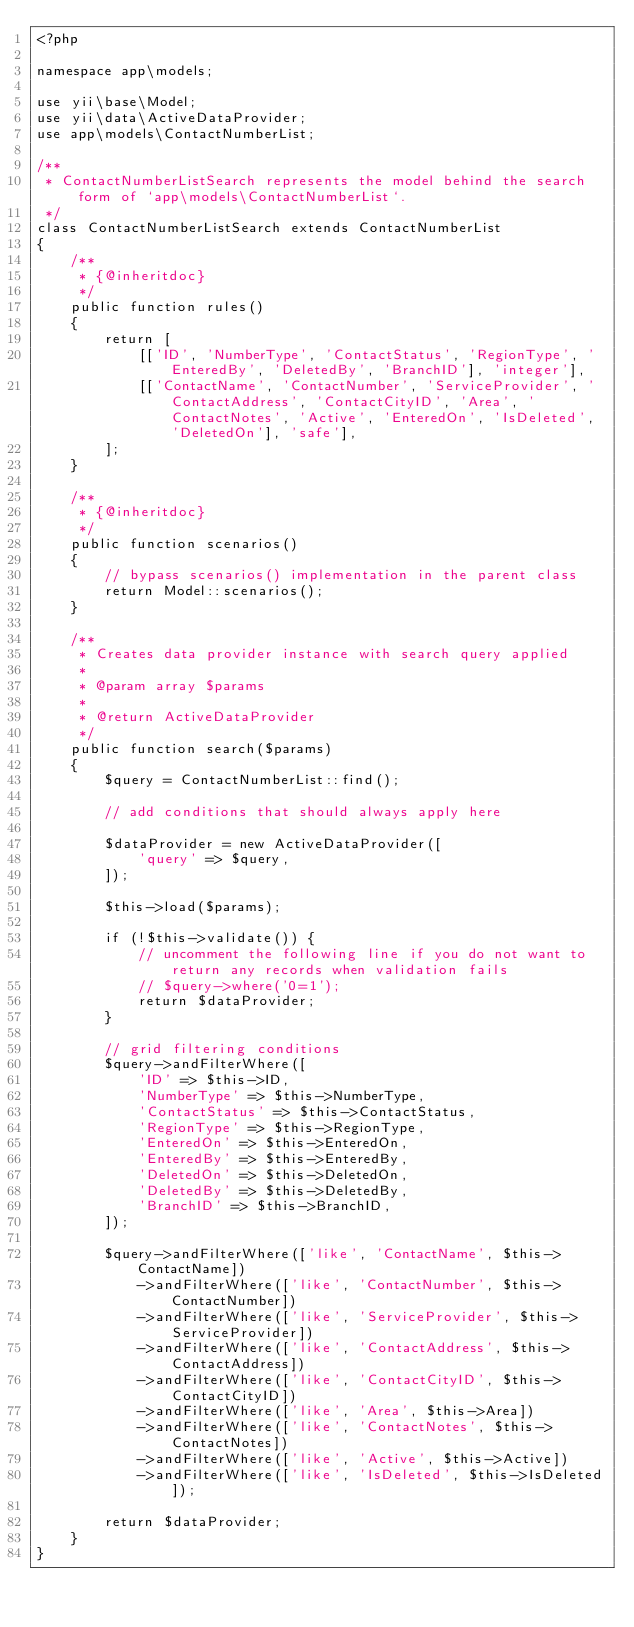<code> <loc_0><loc_0><loc_500><loc_500><_PHP_><?php

namespace app\models;

use yii\base\Model;
use yii\data\ActiveDataProvider;
use app\models\ContactNumberList;

/**
 * ContactNumberListSearch represents the model behind the search form of `app\models\ContactNumberList`.
 */
class ContactNumberListSearch extends ContactNumberList
{
    /**
     * {@inheritdoc}
     */
    public function rules()
    {
        return [
            [['ID', 'NumberType', 'ContactStatus', 'RegionType', 'EnteredBy', 'DeletedBy', 'BranchID'], 'integer'],
            [['ContactName', 'ContactNumber', 'ServiceProvider', 'ContactAddress', 'ContactCityID', 'Area', 'ContactNotes', 'Active', 'EnteredOn', 'IsDeleted', 'DeletedOn'], 'safe'],
        ];
    }

    /**
     * {@inheritdoc}
     */
    public function scenarios()
    {
        // bypass scenarios() implementation in the parent class
        return Model::scenarios();
    }

    /**
     * Creates data provider instance with search query applied
     *
     * @param array $params
     *
     * @return ActiveDataProvider
     */
    public function search($params)
    {
        $query = ContactNumberList::find();

        // add conditions that should always apply here

        $dataProvider = new ActiveDataProvider([
            'query' => $query,
        ]);

        $this->load($params);

        if (!$this->validate()) {
            // uncomment the following line if you do not want to return any records when validation fails
            // $query->where('0=1');
            return $dataProvider;
        }

        // grid filtering conditions
        $query->andFilterWhere([
            'ID' => $this->ID,
            'NumberType' => $this->NumberType,
            'ContactStatus' => $this->ContactStatus,
            'RegionType' => $this->RegionType,
            'EnteredOn' => $this->EnteredOn,
            'EnteredBy' => $this->EnteredBy,
            'DeletedOn' => $this->DeletedOn,
            'DeletedBy' => $this->DeletedBy,
            'BranchID' => $this->BranchID,
        ]);

        $query->andFilterWhere(['like', 'ContactName', $this->ContactName])
            ->andFilterWhere(['like', 'ContactNumber', $this->ContactNumber])
            ->andFilterWhere(['like', 'ServiceProvider', $this->ServiceProvider])
            ->andFilterWhere(['like', 'ContactAddress', $this->ContactAddress])
            ->andFilterWhere(['like', 'ContactCityID', $this->ContactCityID])
            ->andFilterWhere(['like', 'Area', $this->Area])
            ->andFilterWhere(['like', 'ContactNotes', $this->ContactNotes])
            ->andFilterWhere(['like', 'Active', $this->Active])
            ->andFilterWhere(['like', 'IsDeleted', $this->IsDeleted]);

        return $dataProvider;
    }
}
</code> 